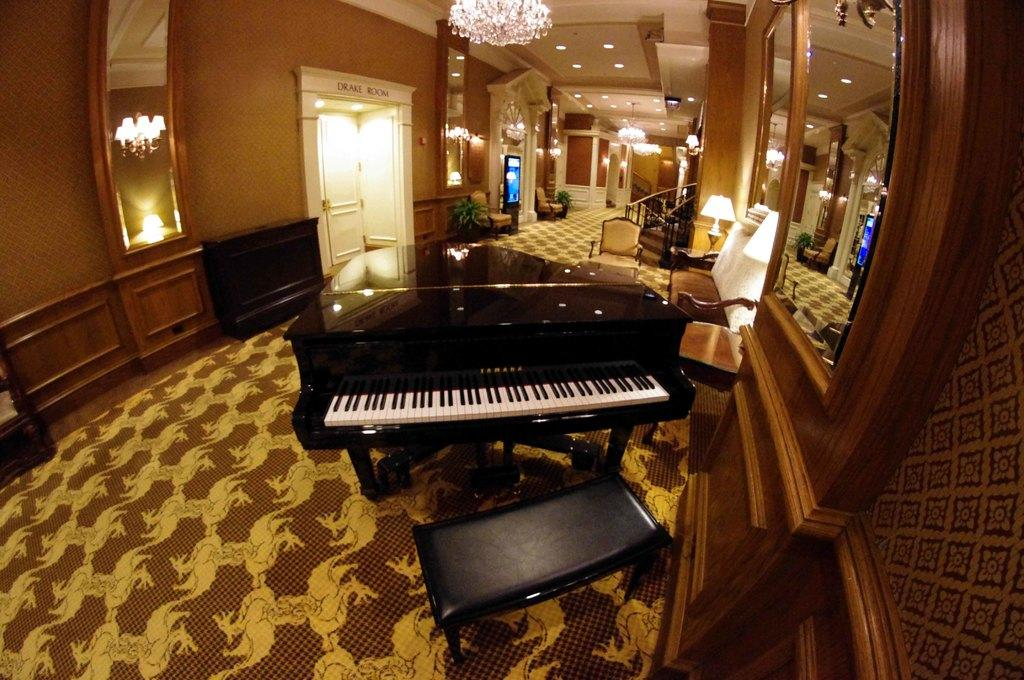What musical instrument is present in the image? There is a piano in the image. What furniture is present for seating near the piano? There is a bench and a chair in the image. What architectural feature is present in the image? There are steps in the image. What type of lighting is present in the image? There are lights on the ceiling and a lamp in the image. What reflective surface is present in the image? There is a mirror in the image. What type of entrance is present in the image? There is a door in the image. What type of apparel is hanging from the piano in the image? There is no apparel hanging from the piano in the image. What type of thread is used to create the pattern on the piano keys? The piano keys do not have a pattern created by thread; they are made of materials such as plastic or wood. 